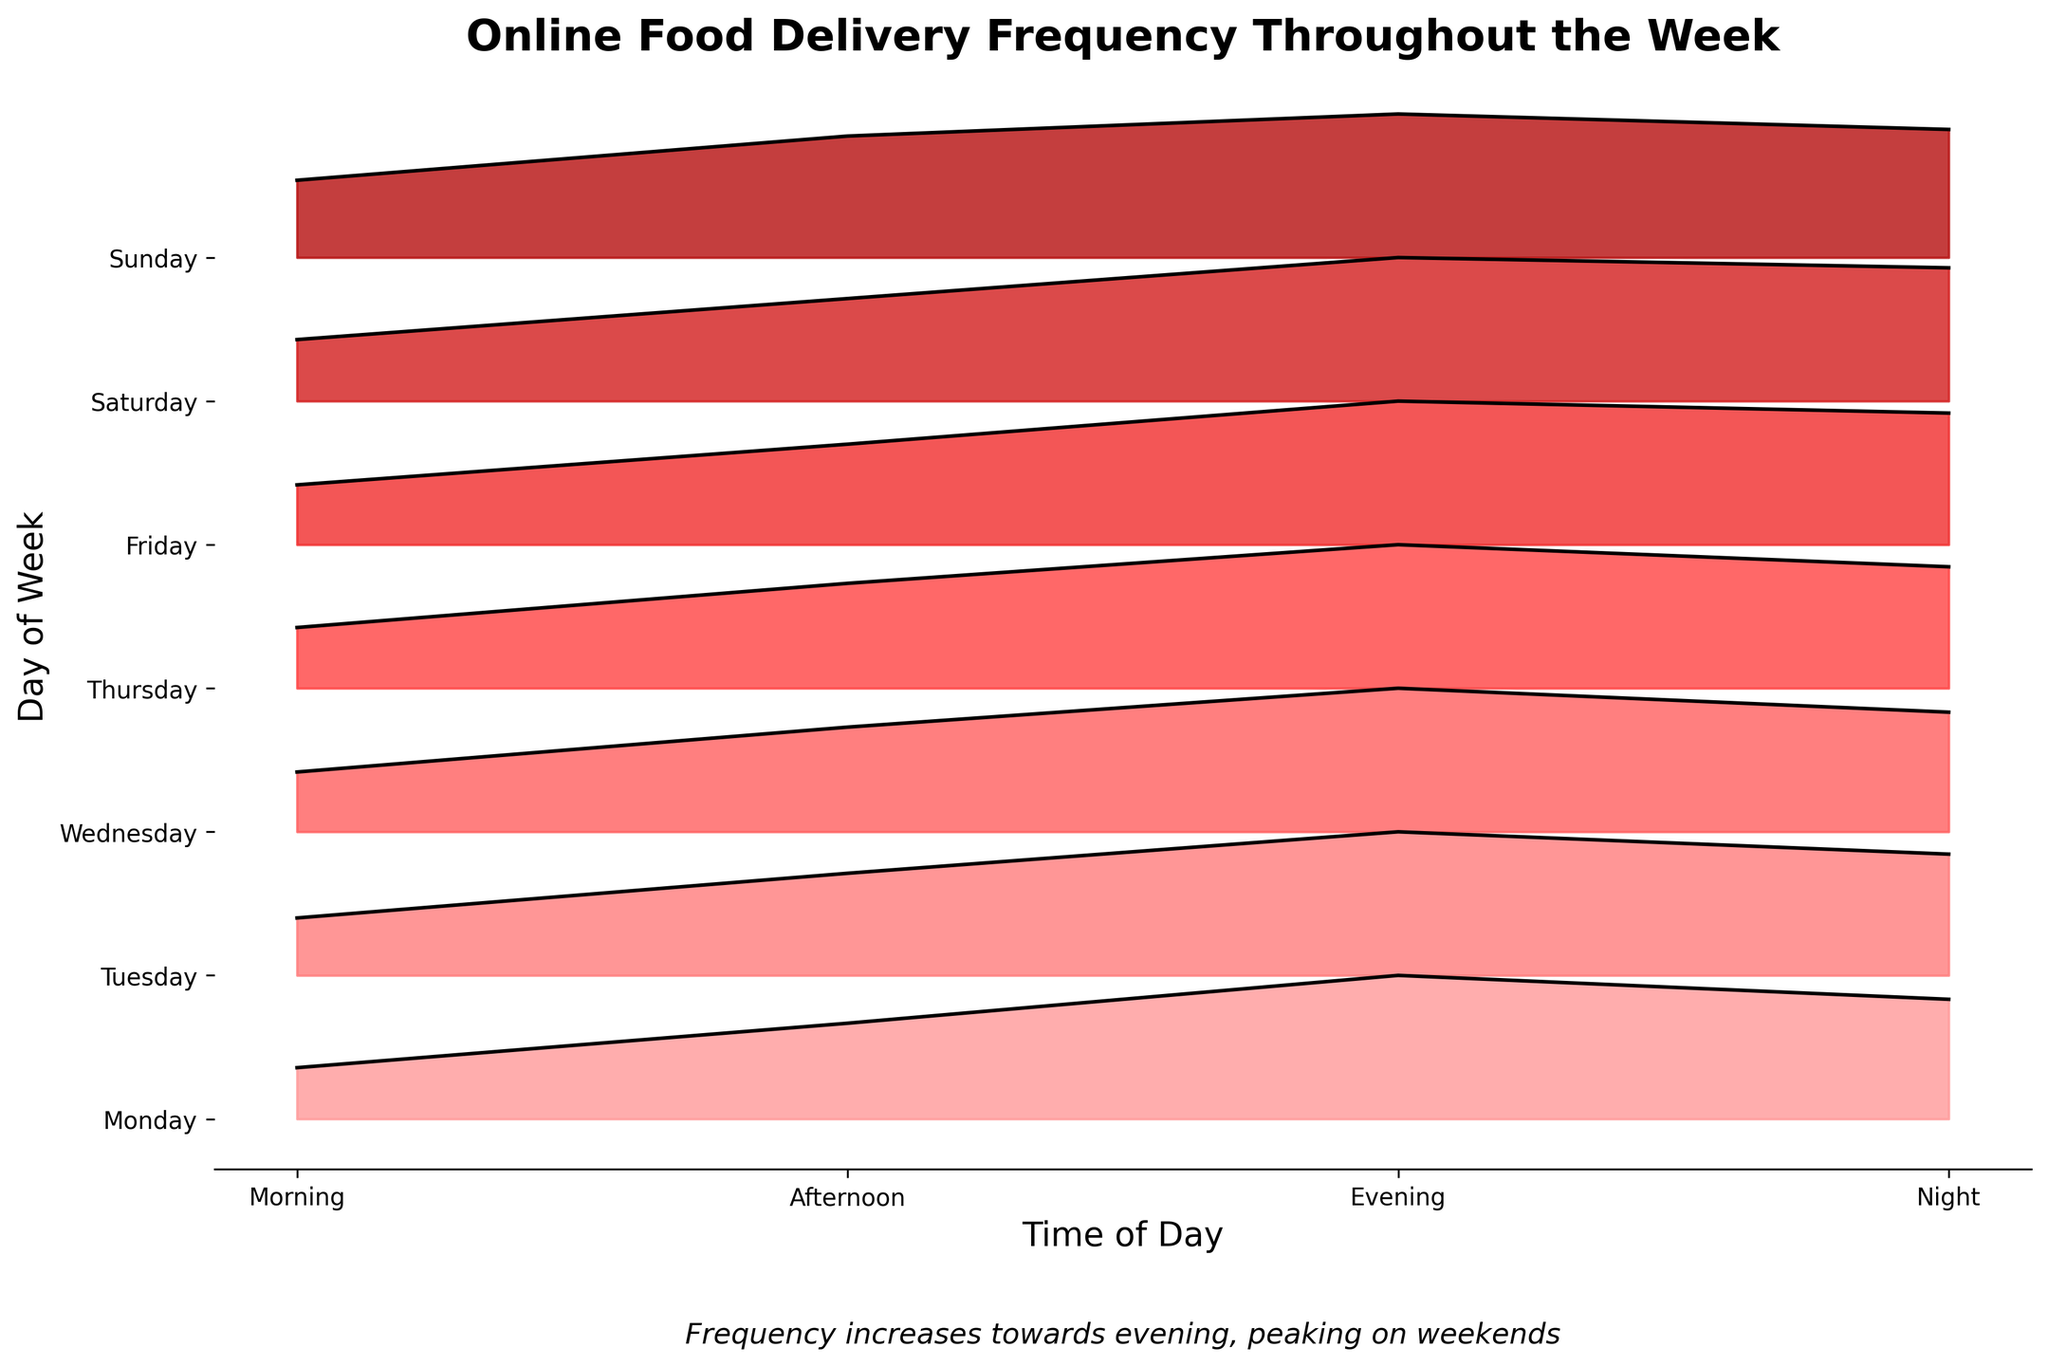What is the title of the plot? The title of the plot is displayed at the top and reads "Online Food Delivery Frequency Throughout the Week".
Answer: Online Food Delivery Frequency Throughout the Week What day shows the highest frequency of online food delivery orders? By scanning the plot, we can see that Sunday has the highest peaks, particularly in the evening and night.
Answer: Sunday What is the general trend in online food delivery frequency throughout the day? The plot shows that the frequency increases from morning to evening, with a slight drop at night.
Answer: Increase from morning to evening, slight drop at night Which time period on Monday has the highest delivery frequency? Looking at the ridgeline for Monday, it peaks in the evening.
Answer: Evening How does the delivery frequency on Tuesday evening compare to Wednesday evening? By comparing the ridgeline heights, it is clear that Tuesday evening's frequency is slightly less than Wednesday evening's.
Answer: Less than Wednesday evening What pattern do you observe in terms of delivery frequency during weekends compared to weekdays? The ridgeline plots for Saturday and Sunday have generally higher peaks than those of the weekdays, indicating higher delivery frequencies during weekends.
Answer: Higher during weekends What is the difference in frequency between Saturday night and Thursday night? The peak for Saturday night is much higher compared to Thursday night. Specifically, Saturday night has a peak of 65, while Thursday night has 44. The difference is 65 - 44.
Answer: 21 Which day has the lowest delivery frequency in the morning? From the ridgeline plot, Monday has the lowest morning frequency.
Answer: Monday What time of day has the most consistent delivery frequency across all days? Looking at the ridgeline plot, the evening time consistently shows high peaks across all days.
Answer: Evening On which day does the afternoon delivery frequency peak the highest, and what is the value? By checking the ridgeline for each day during the afternoon, we can see Sunday has the highest peak at 55.
Answer: Sunday, 55 